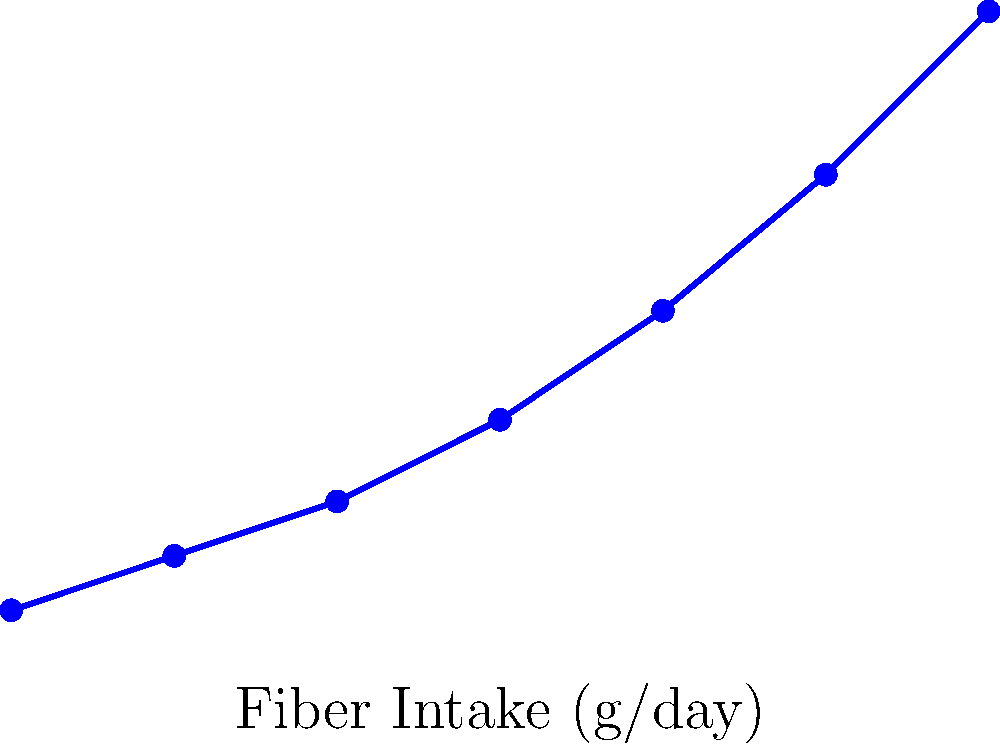Based on the line graph showing the relationship between fiber intake and short-chain fatty acid (SCFA) production in the colon, what can be concluded about the nature of this relationship? To answer this question, let's analyze the graph step-by-step:

1. Observe the overall trend: As we move from left to right on the x-axis (increasing fiber intake), we see a consistent increase in the y-axis values (SCFA production).

2. Examine the shape of the line: The line is not straight but curves upward, becoming steeper as it moves to the right.

3. Analyze the rate of change: The increase in SCFA production is not constant for equal increases in fiber intake. For example:
   - From 0 to 5 g/day of fiber, SCFA production increases by about 2 mmol/L
   - From 25 to 30 g/day of fiber, SCFA production increases by about 6 mmol/L

4. Interpret the relationship: This pattern indicates a non-linear, positive relationship between fiber intake and SCFA production. Specifically, it suggests an exponential or accelerating relationship.

5. Consider the biological context: This relationship aligns with our understanding of gut microbiome function. As fiber intake increases, it provides more substrate for gut bacteria, leading to increased SCFA production. The accelerating nature of the relationship could be due to factors such as microbial population growth or increased enzymatic activity with higher substrate availability.

Given these observations, we can conclude that there is a positive, non-linear relationship between fiber intake and SCFA production, with SCFA production increasing at an accelerating rate as fiber intake increases.
Answer: Positive, non-linear relationship with accelerating SCFA production as fiber intake increases. 